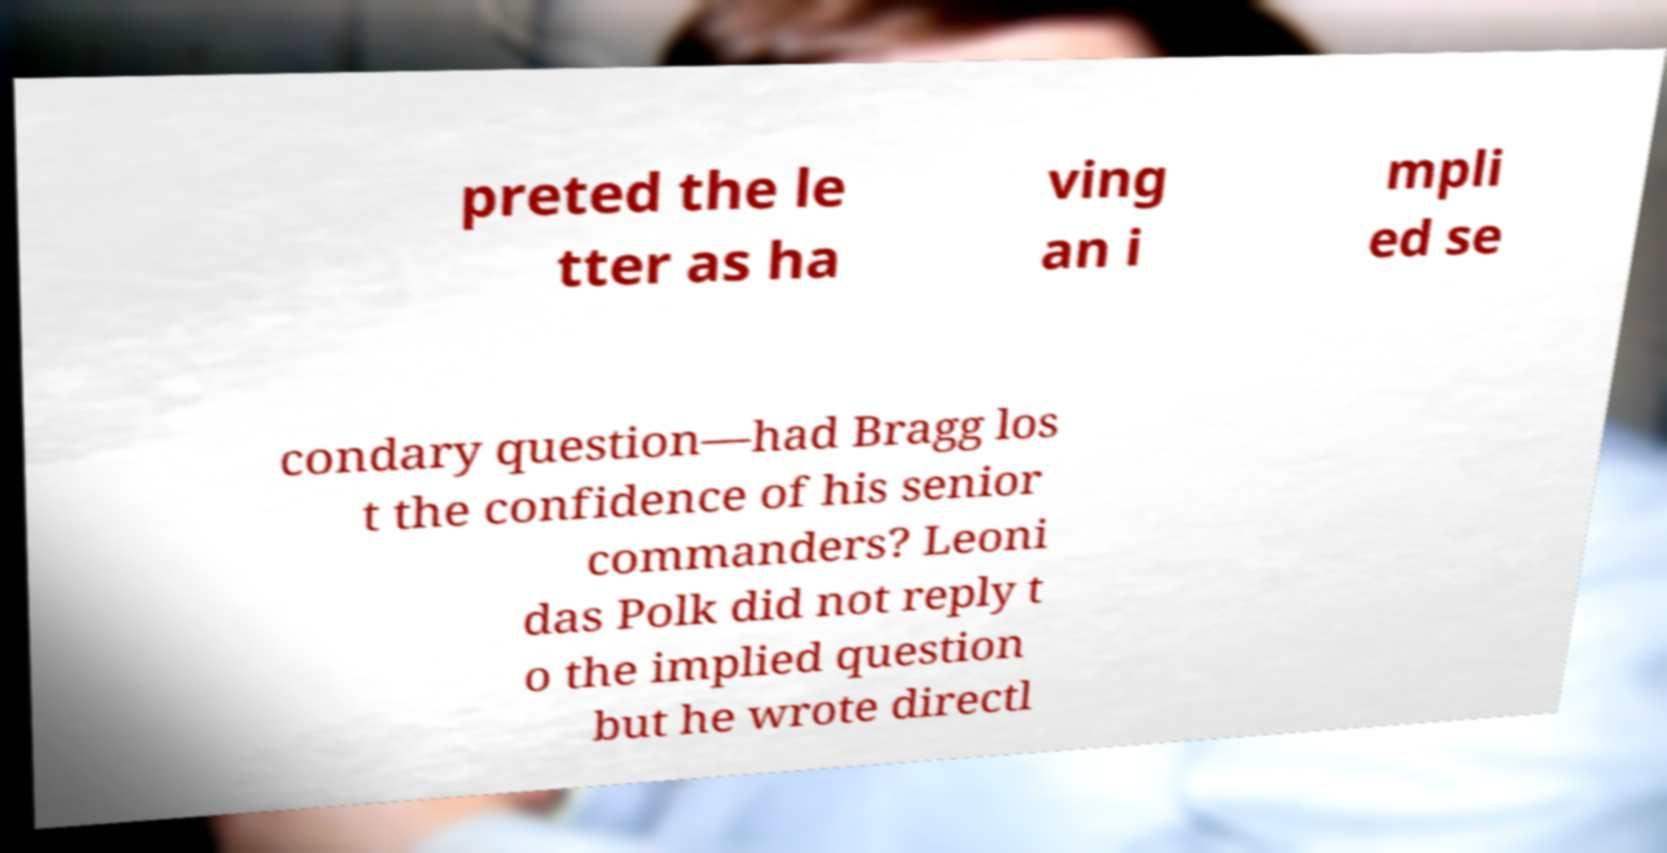For documentation purposes, I need the text within this image transcribed. Could you provide that? preted the le tter as ha ving an i mpli ed se condary question—had Bragg los t the confidence of his senior commanders? Leoni das Polk did not reply t o the implied question but he wrote directl 